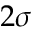Convert formula to latex. <formula><loc_0><loc_0><loc_500><loc_500>2 \sigma</formula> 